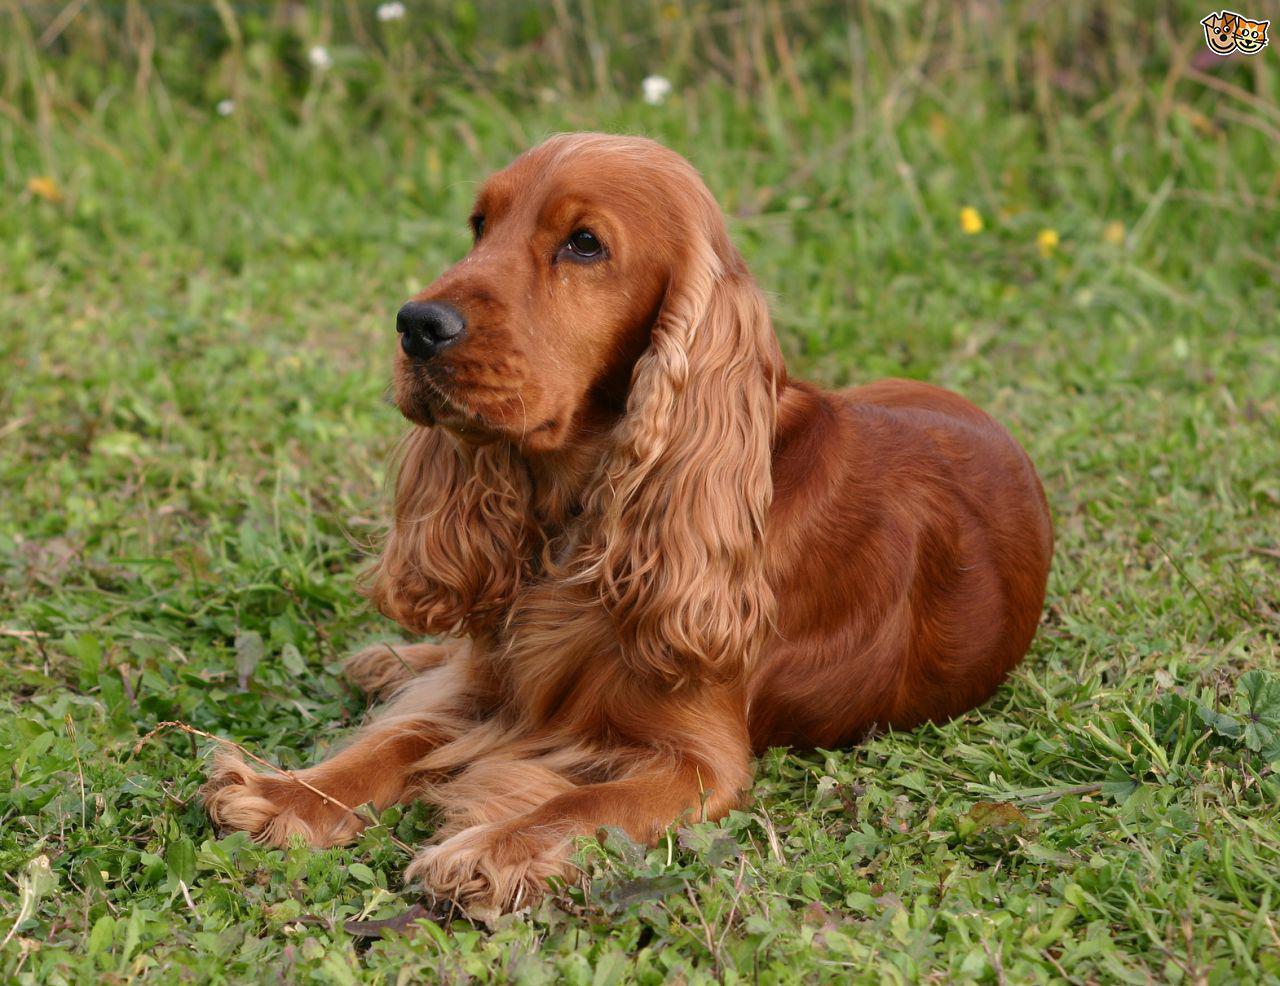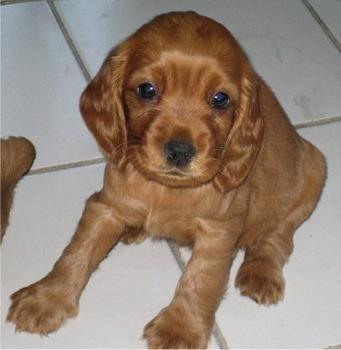The first image is the image on the left, the second image is the image on the right. Given the left and right images, does the statement "Together, the two images show a puppy and a full-grown spaniel." hold true? Answer yes or no. Yes. 